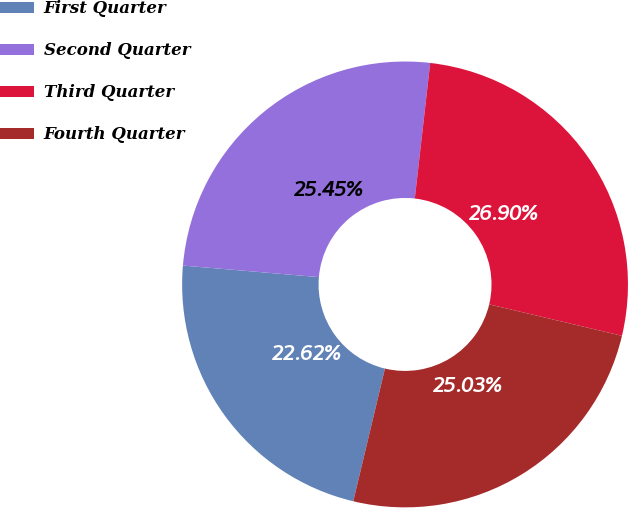<chart> <loc_0><loc_0><loc_500><loc_500><pie_chart><fcel>First Quarter<fcel>Second Quarter<fcel>Third Quarter<fcel>Fourth Quarter<nl><fcel>22.62%<fcel>25.45%<fcel>26.9%<fcel>25.03%<nl></chart> 